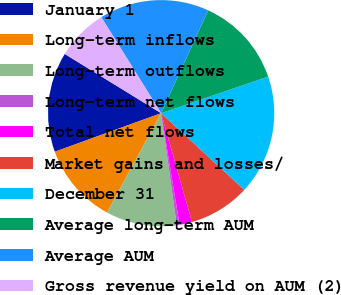Convert chart to OTSL. <chart><loc_0><loc_0><loc_500><loc_500><pie_chart><fcel>January 1<fcel>Long-term inflows<fcel>Long-term outflows<fcel>Long-term net flows<fcel>Total net flows<fcel>Market gains and losses/<fcel>December 31<fcel>Average long-term AUM<fcel>Average AUM<fcel>Gross revenue yield on AUM (2)<nl><fcel>14.31%<fcel>11.53%<fcel>10.14%<fcel>0.4%<fcel>1.79%<fcel>8.75%<fcel>17.1%<fcel>12.92%<fcel>15.71%<fcel>7.36%<nl></chart> 